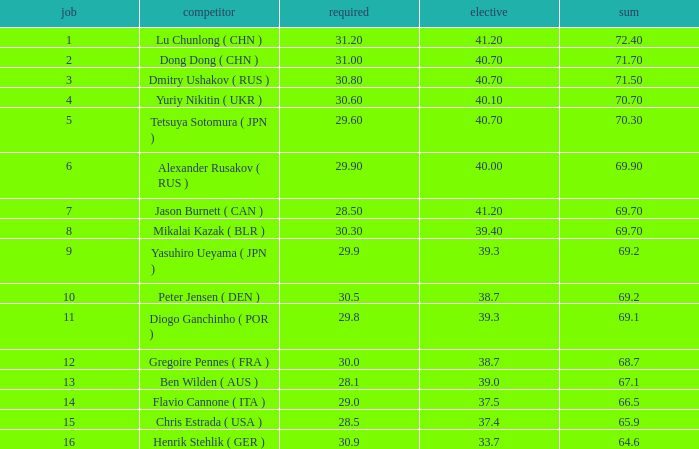What's the total of the position of 1? None. 